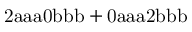<formula> <loc_0><loc_0><loc_500><loc_500>2 a a a 0 b b b + 0 a a a 2 b b b</formula> 